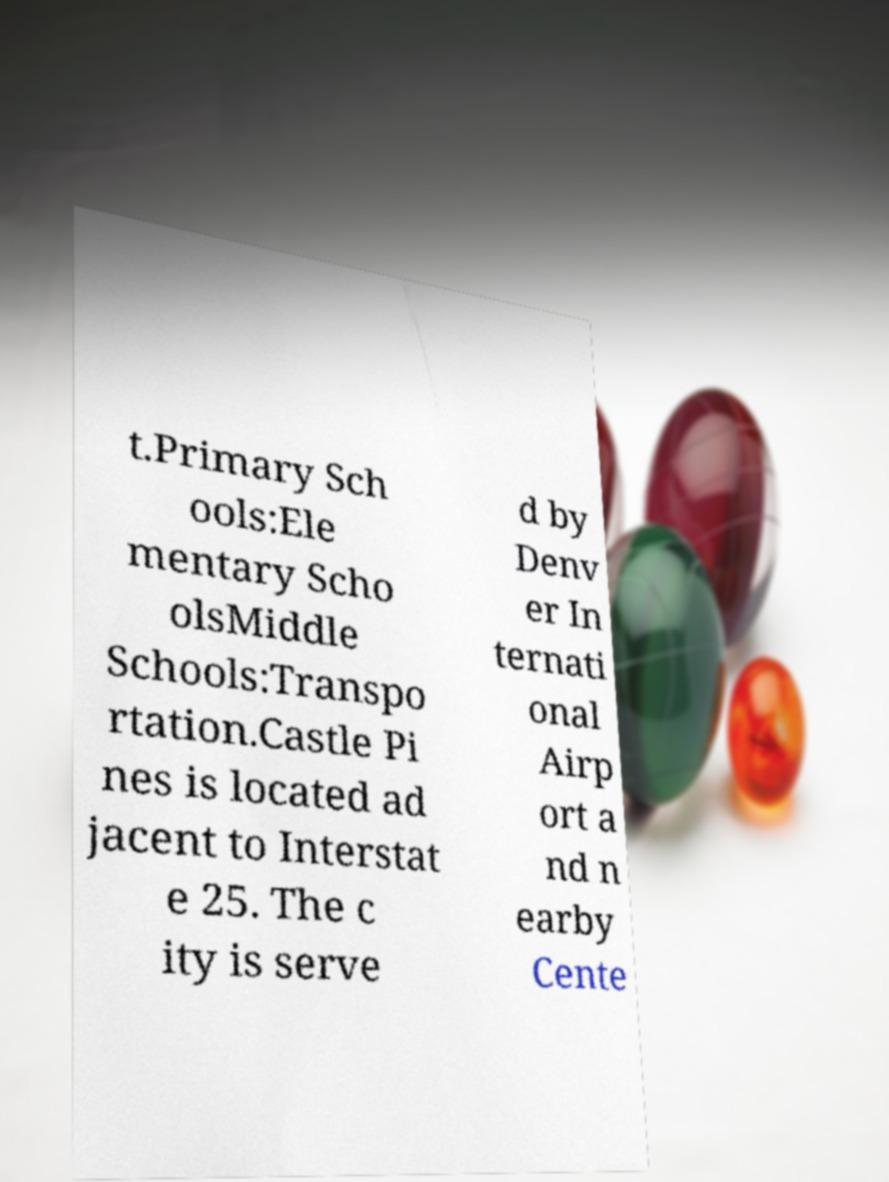There's text embedded in this image that I need extracted. Can you transcribe it verbatim? t.Primary Sch ools:Ele mentary Scho olsMiddle Schools:Transpo rtation.Castle Pi nes is located ad jacent to Interstat e 25. The c ity is serve d by Denv er In ternati onal Airp ort a nd n earby Cente 